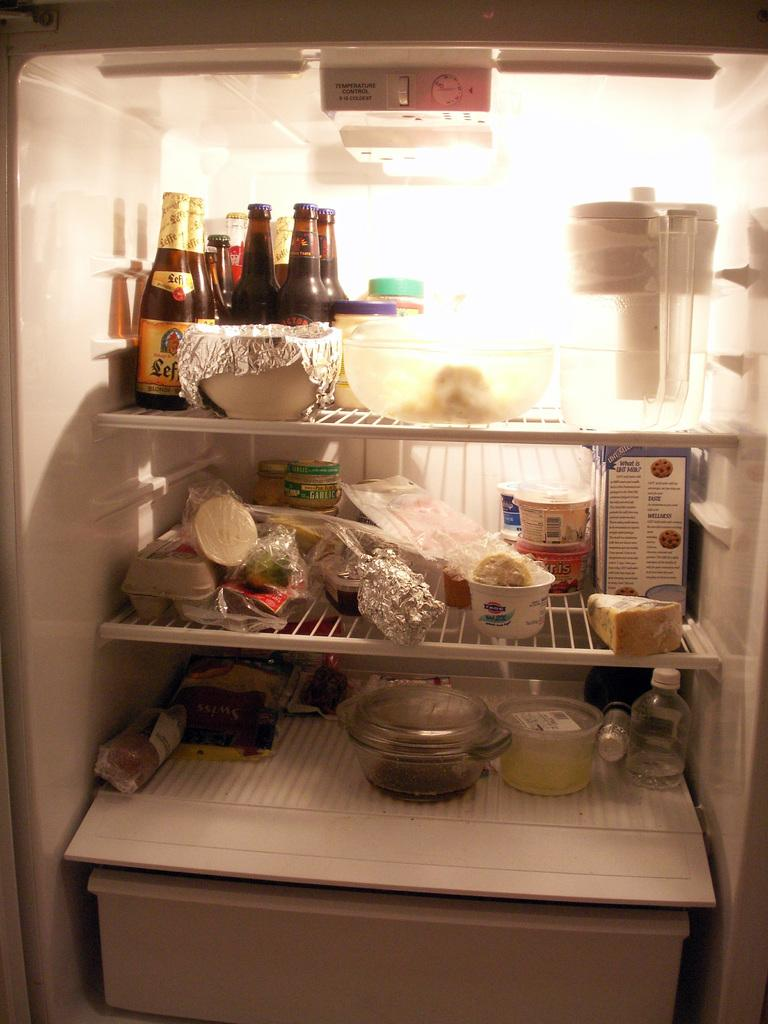What is the main subject of the image? The main subject of the image is the interior of a refrigerator. How many shelves are visible in the refrigerator? The refrigerator has three shelves. What types of items can be seen on the shelves? Eatables and drinks are placed on the shelves. What type of bait is used to catch fish in the image? There is no mention of fish or bait in the image; it shows the interior of a refrigerator with shelves containing eatables and drinks. 